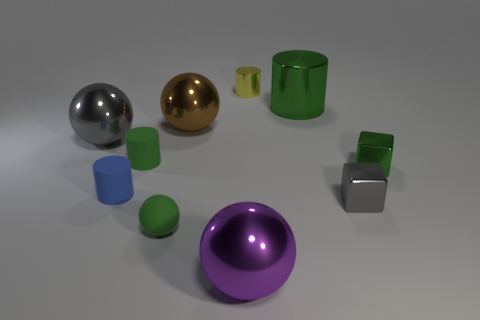Does the cylinder that is on the right side of the yellow cylinder have the same size as the gray thing that is on the right side of the big green cylinder?
Your answer should be very brief. No. What is the shape of the thing that is both behind the green rubber cylinder and on the left side of the tiny green ball?
Provide a succinct answer. Sphere. Is there a big cyan ball made of the same material as the big purple object?
Offer a very short reply. No. There is a small cube that is the same color as the large shiny cylinder; what is its material?
Keep it short and to the point. Metal. Does the small object that is in front of the gray block have the same material as the green thing behind the large brown object?
Keep it short and to the point. No. Are there more green blocks than cyan cubes?
Offer a terse response. Yes. The small cylinder behind the metal cylinder in front of the metallic object behind the big green shiny cylinder is what color?
Offer a very short reply. Yellow. There is a metal cube in front of the green block; does it have the same color as the tiny matte cylinder behind the tiny green block?
Your response must be concise. No. How many big brown objects are on the left side of the big object to the right of the yellow cylinder?
Provide a succinct answer. 1. Is there a tiny green shiny object?
Keep it short and to the point. Yes. 